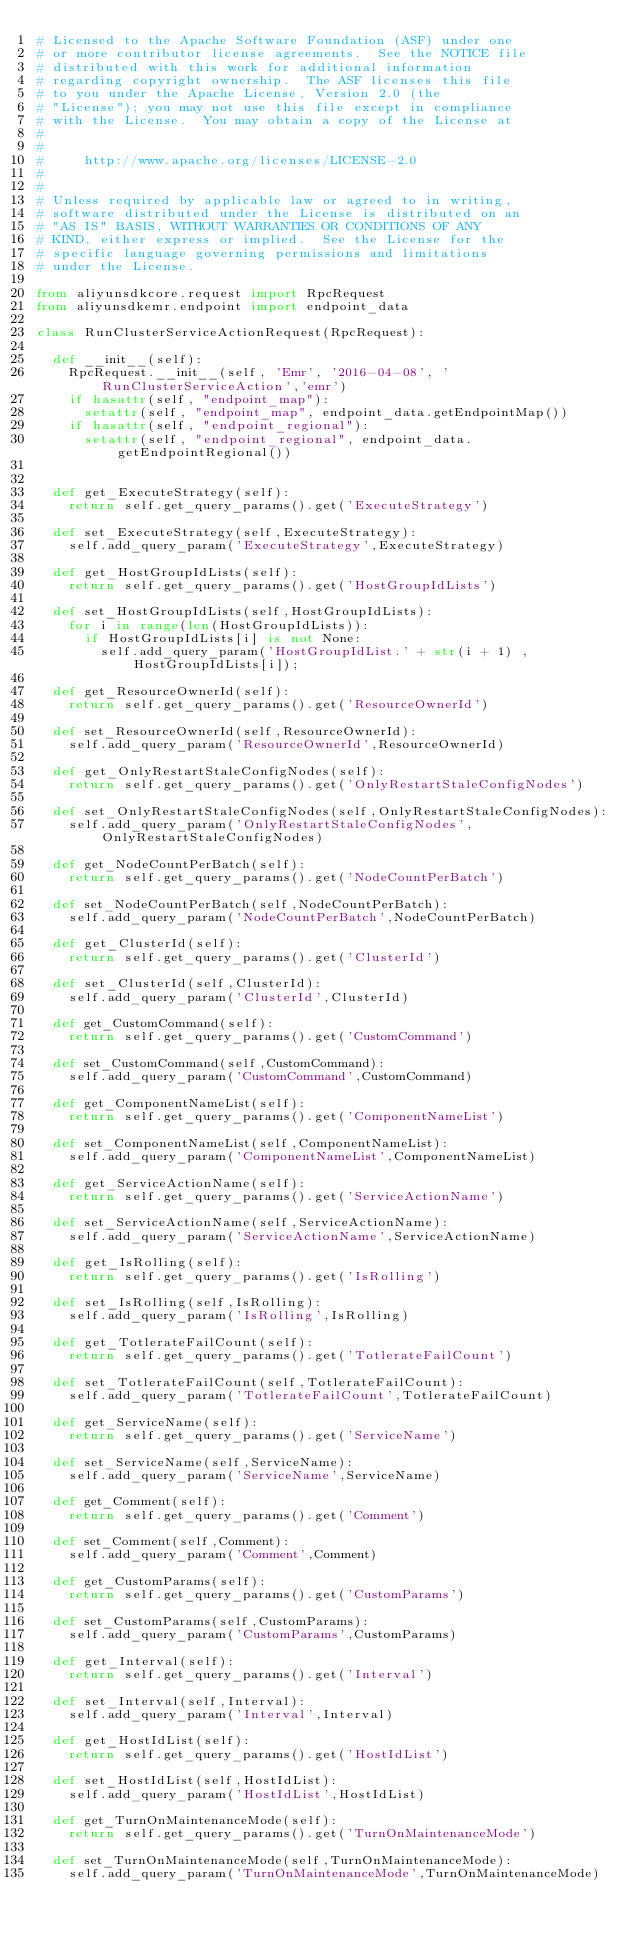<code> <loc_0><loc_0><loc_500><loc_500><_Python_># Licensed to the Apache Software Foundation (ASF) under one
# or more contributor license agreements.  See the NOTICE file
# distributed with this work for additional information
# regarding copyright ownership.  The ASF licenses this file
# to you under the Apache License, Version 2.0 (the
# "License"); you may not use this file except in compliance
# with the License.  You may obtain a copy of the License at
#
#
#     http://www.apache.org/licenses/LICENSE-2.0
#
#
# Unless required by applicable law or agreed to in writing,
# software distributed under the License is distributed on an
# "AS IS" BASIS, WITHOUT WARRANTIES OR CONDITIONS OF ANY
# KIND, either express or implied.  See the License for the
# specific language governing permissions and limitations
# under the License.

from aliyunsdkcore.request import RpcRequest
from aliyunsdkemr.endpoint import endpoint_data

class RunClusterServiceActionRequest(RpcRequest):

	def __init__(self):
		RpcRequest.__init__(self, 'Emr', '2016-04-08', 'RunClusterServiceAction','emr')
		if hasattr(self, "endpoint_map"):
			setattr(self, "endpoint_map", endpoint_data.getEndpointMap())
		if hasattr(self, "endpoint_regional"):
			setattr(self, "endpoint_regional", endpoint_data.getEndpointRegional())


	def get_ExecuteStrategy(self):
		return self.get_query_params().get('ExecuteStrategy')

	def set_ExecuteStrategy(self,ExecuteStrategy):
		self.add_query_param('ExecuteStrategy',ExecuteStrategy)

	def get_HostGroupIdLists(self):
		return self.get_query_params().get('HostGroupIdLists')

	def set_HostGroupIdLists(self,HostGroupIdLists):
		for i in range(len(HostGroupIdLists)):	
			if HostGroupIdLists[i] is not None:
				self.add_query_param('HostGroupIdList.' + str(i + 1) , HostGroupIdLists[i]);

	def get_ResourceOwnerId(self):
		return self.get_query_params().get('ResourceOwnerId')

	def set_ResourceOwnerId(self,ResourceOwnerId):
		self.add_query_param('ResourceOwnerId',ResourceOwnerId)

	def get_OnlyRestartStaleConfigNodes(self):
		return self.get_query_params().get('OnlyRestartStaleConfigNodes')

	def set_OnlyRestartStaleConfigNodes(self,OnlyRestartStaleConfigNodes):
		self.add_query_param('OnlyRestartStaleConfigNodes',OnlyRestartStaleConfigNodes)

	def get_NodeCountPerBatch(self):
		return self.get_query_params().get('NodeCountPerBatch')

	def set_NodeCountPerBatch(self,NodeCountPerBatch):
		self.add_query_param('NodeCountPerBatch',NodeCountPerBatch)

	def get_ClusterId(self):
		return self.get_query_params().get('ClusterId')

	def set_ClusterId(self,ClusterId):
		self.add_query_param('ClusterId',ClusterId)

	def get_CustomCommand(self):
		return self.get_query_params().get('CustomCommand')

	def set_CustomCommand(self,CustomCommand):
		self.add_query_param('CustomCommand',CustomCommand)

	def get_ComponentNameList(self):
		return self.get_query_params().get('ComponentNameList')

	def set_ComponentNameList(self,ComponentNameList):
		self.add_query_param('ComponentNameList',ComponentNameList)

	def get_ServiceActionName(self):
		return self.get_query_params().get('ServiceActionName')

	def set_ServiceActionName(self,ServiceActionName):
		self.add_query_param('ServiceActionName',ServiceActionName)

	def get_IsRolling(self):
		return self.get_query_params().get('IsRolling')

	def set_IsRolling(self,IsRolling):
		self.add_query_param('IsRolling',IsRolling)

	def get_TotlerateFailCount(self):
		return self.get_query_params().get('TotlerateFailCount')

	def set_TotlerateFailCount(self,TotlerateFailCount):
		self.add_query_param('TotlerateFailCount',TotlerateFailCount)

	def get_ServiceName(self):
		return self.get_query_params().get('ServiceName')

	def set_ServiceName(self,ServiceName):
		self.add_query_param('ServiceName',ServiceName)

	def get_Comment(self):
		return self.get_query_params().get('Comment')

	def set_Comment(self,Comment):
		self.add_query_param('Comment',Comment)

	def get_CustomParams(self):
		return self.get_query_params().get('CustomParams')

	def set_CustomParams(self,CustomParams):
		self.add_query_param('CustomParams',CustomParams)

	def get_Interval(self):
		return self.get_query_params().get('Interval')

	def set_Interval(self,Interval):
		self.add_query_param('Interval',Interval)

	def get_HostIdList(self):
		return self.get_query_params().get('HostIdList')

	def set_HostIdList(self,HostIdList):
		self.add_query_param('HostIdList',HostIdList)

	def get_TurnOnMaintenanceMode(self):
		return self.get_query_params().get('TurnOnMaintenanceMode')

	def set_TurnOnMaintenanceMode(self,TurnOnMaintenanceMode):
		self.add_query_param('TurnOnMaintenanceMode',TurnOnMaintenanceMode)</code> 